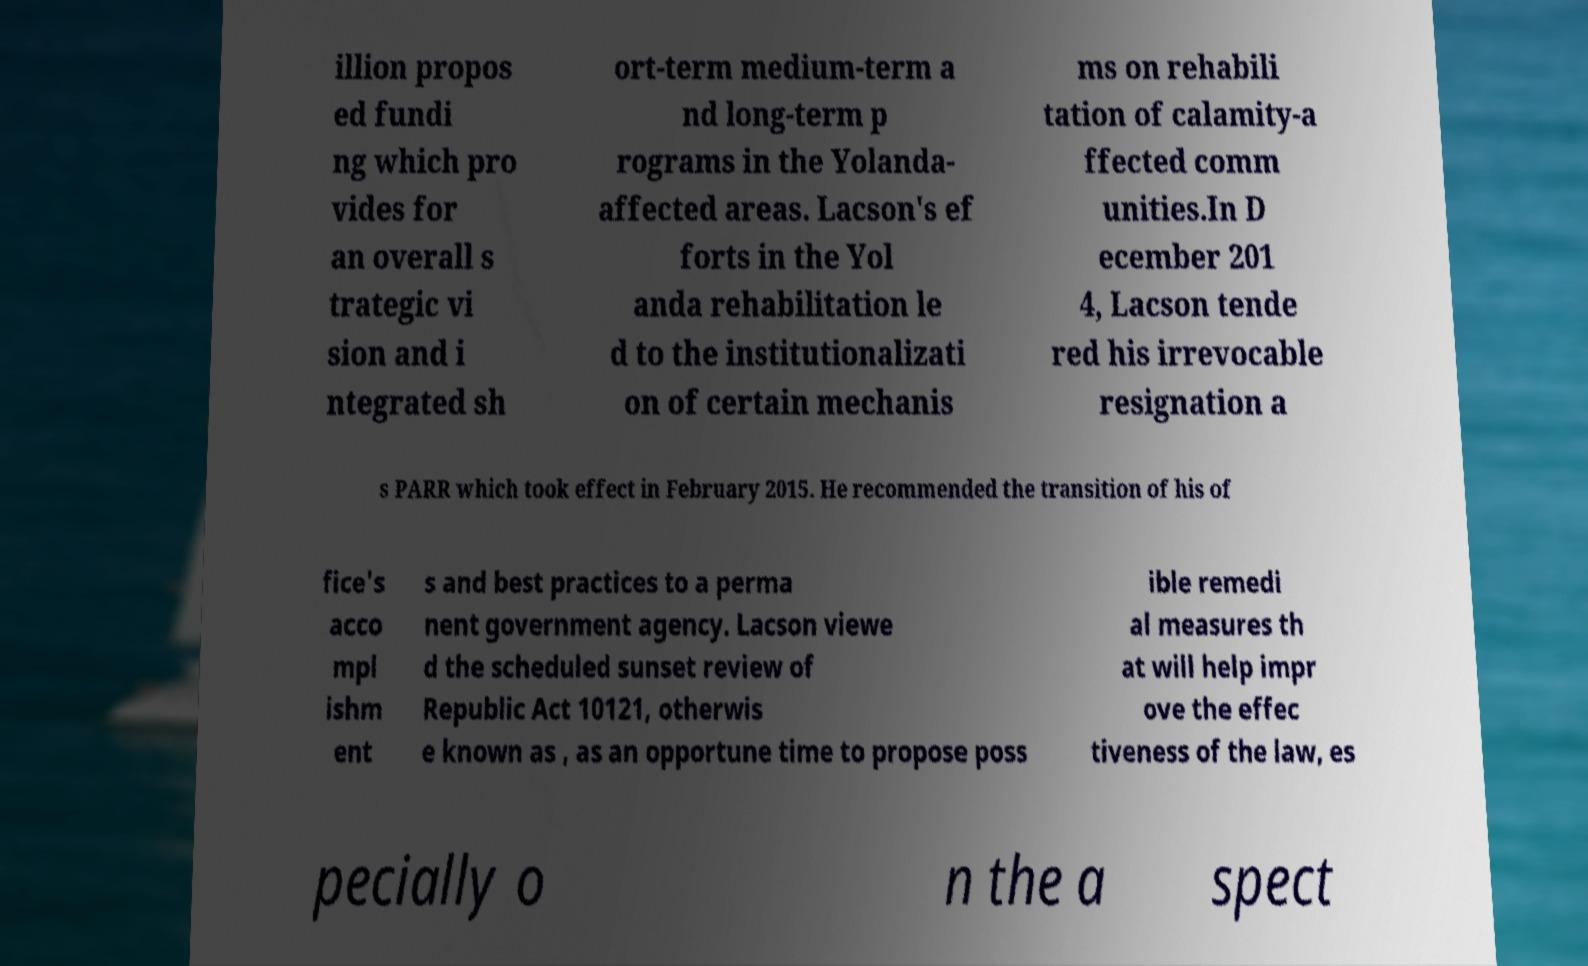Can you read and provide the text displayed in the image?This photo seems to have some interesting text. Can you extract and type it out for me? illion propos ed fundi ng which pro vides for an overall s trategic vi sion and i ntegrated sh ort-term medium-term a nd long-term p rograms in the Yolanda- affected areas. Lacson's ef forts in the Yol anda rehabilitation le d to the institutionalizati on of certain mechanis ms on rehabili tation of calamity-a ffected comm unities.In D ecember 201 4, Lacson tende red his irrevocable resignation a s PARR which took effect in February 2015. He recommended the transition of his of fice's acco mpl ishm ent s and best practices to a perma nent government agency. Lacson viewe d the scheduled sunset review of Republic Act 10121, otherwis e known as , as an opportune time to propose poss ible remedi al measures th at will help impr ove the effec tiveness of the law, es pecially o n the a spect 